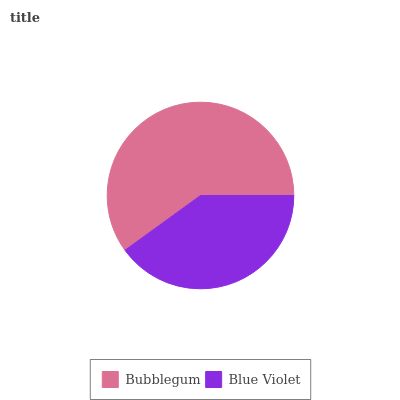Is Blue Violet the minimum?
Answer yes or no. Yes. Is Bubblegum the maximum?
Answer yes or no. Yes. Is Blue Violet the maximum?
Answer yes or no. No. Is Bubblegum greater than Blue Violet?
Answer yes or no. Yes. Is Blue Violet less than Bubblegum?
Answer yes or no. Yes. Is Blue Violet greater than Bubblegum?
Answer yes or no. No. Is Bubblegum less than Blue Violet?
Answer yes or no. No. Is Bubblegum the high median?
Answer yes or no. Yes. Is Blue Violet the low median?
Answer yes or no. Yes. Is Blue Violet the high median?
Answer yes or no. No. Is Bubblegum the low median?
Answer yes or no. No. 